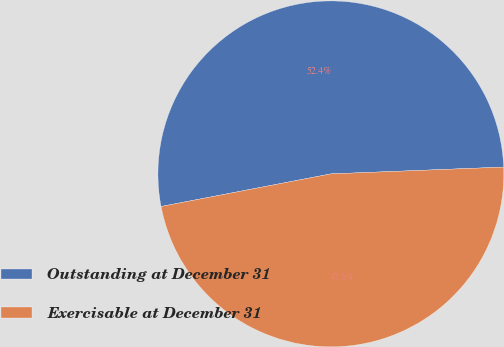Convert chart. <chart><loc_0><loc_0><loc_500><loc_500><pie_chart><fcel>Outstanding at December 31<fcel>Exercisable at December 31<nl><fcel>52.39%<fcel>47.61%<nl></chart> 